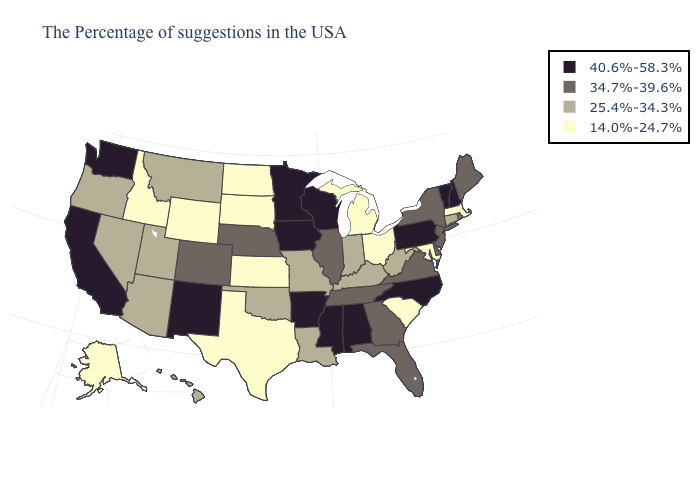What is the lowest value in the MidWest?
Short answer required. 14.0%-24.7%. Name the states that have a value in the range 14.0%-24.7%?
Be succinct. Massachusetts, Maryland, South Carolina, Ohio, Michigan, Kansas, Texas, South Dakota, North Dakota, Wyoming, Idaho, Alaska. Does Oregon have a lower value than Kansas?
Keep it brief. No. Name the states that have a value in the range 25.4%-34.3%?
Give a very brief answer. Connecticut, West Virginia, Kentucky, Indiana, Louisiana, Missouri, Oklahoma, Utah, Montana, Arizona, Nevada, Oregon, Hawaii. Name the states that have a value in the range 25.4%-34.3%?
Answer briefly. Connecticut, West Virginia, Kentucky, Indiana, Louisiana, Missouri, Oklahoma, Utah, Montana, Arizona, Nevada, Oregon, Hawaii. What is the lowest value in states that border Kentucky?
Keep it brief. 14.0%-24.7%. Name the states that have a value in the range 25.4%-34.3%?
Be succinct. Connecticut, West Virginia, Kentucky, Indiana, Louisiana, Missouri, Oklahoma, Utah, Montana, Arizona, Nevada, Oregon, Hawaii. Name the states that have a value in the range 25.4%-34.3%?
Be succinct. Connecticut, West Virginia, Kentucky, Indiana, Louisiana, Missouri, Oklahoma, Utah, Montana, Arizona, Nevada, Oregon, Hawaii. Does Washington have the highest value in the West?
Answer briefly. Yes. Does Iowa have the lowest value in the USA?
Concise answer only. No. Does the map have missing data?
Short answer required. No. Among the states that border Virginia , which have the highest value?
Write a very short answer. North Carolina. Which states have the lowest value in the USA?
Answer briefly. Massachusetts, Maryland, South Carolina, Ohio, Michigan, Kansas, Texas, South Dakota, North Dakota, Wyoming, Idaho, Alaska. Name the states that have a value in the range 25.4%-34.3%?
Answer briefly. Connecticut, West Virginia, Kentucky, Indiana, Louisiana, Missouri, Oklahoma, Utah, Montana, Arizona, Nevada, Oregon, Hawaii. What is the lowest value in the South?
Write a very short answer. 14.0%-24.7%. 